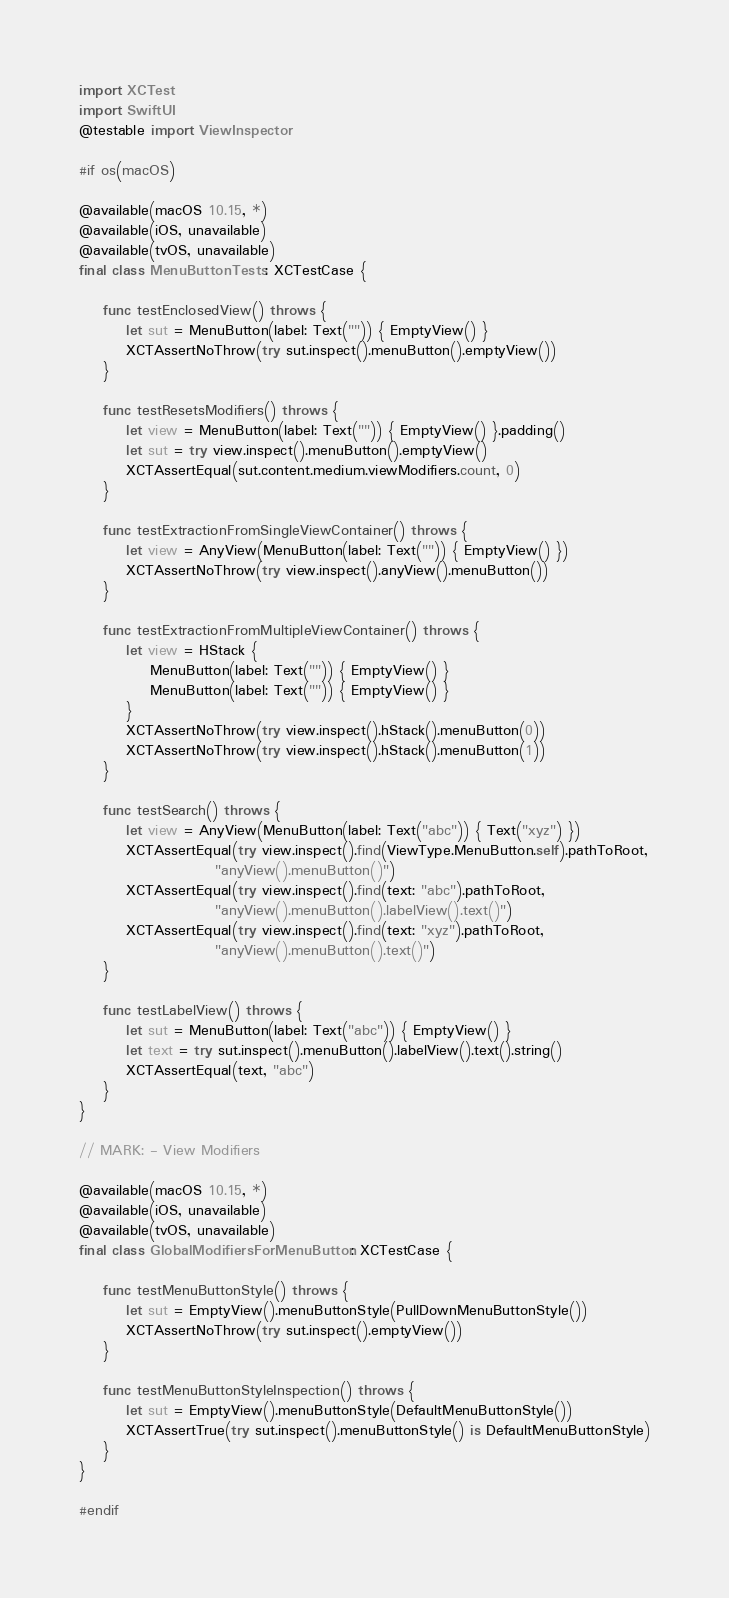Convert code to text. <code><loc_0><loc_0><loc_500><loc_500><_Swift_>import XCTest
import SwiftUI
@testable import ViewInspector

#if os(macOS)

@available(macOS 10.15, *)
@available(iOS, unavailable)
@available(tvOS, unavailable)
final class MenuButtonTests: XCTestCase {
    
    func testEnclosedView() throws {
        let sut = MenuButton(label: Text("")) { EmptyView() }
        XCTAssertNoThrow(try sut.inspect().menuButton().emptyView())
    }
    
    func testResetsModifiers() throws {
        let view = MenuButton(label: Text("")) { EmptyView() }.padding()
        let sut = try view.inspect().menuButton().emptyView()
        XCTAssertEqual(sut.content.medium.viewModifiers.count, 0)
    }
    
    func testExtractionFromSingleViewContainer() throws {
        let view = AnyView(MenuButton(label: Text("")) { EmptyView() })
        XCTAssertNoThrow(try view.inspect().anyView().menuButton())
    }
    
    func testExtractionFromMultipleViewContainer() throws {
        let view = HStack {
            MenuButton(label: Text("")) { EmptyView() }
            MenuButton(label: Text("")) { EmptyView() }
        }
        XCTAssertNoThrow(try view.inspect().hStack().menuButton(0))
        XCTAssertNoThrow(try view.inspect().hStack().menuButton(1))
    }
    
    func testSearch() throws {
        let view = AnyView(MenuButton(label: Text("abc")) { Text("xyz") })
        XCTAssertEqual(try view.inspect().find(ViewType.MenuButton.self).pathToRoot,
                       "anyView().menuButton()")
        XCTAssertEqual(try view.inspect().find(text: "abc").pathToRoot,
                       "anyView().menuButton().labelView().text()")
        XCTAssertEqual(try view.inspect().find(text: "xyz").pathToRoot,
                       "anyView().menuButton().text()")
    }
    
    func testLabelView() throws {
        let sut = MenuButton(label: Text("abc")) { EmptyView() }
        let text = try sut.inspect().menuButton().labelView().text().string()
        XCTAssertEqual(text, "abc")
    }
}

// MARK: - View Modifiers

@available(macOS 10.15, *)
@available(iOS, unavailable)
@available(tvOS, unavailable)
final class GlobalModifiersForMenuButton: XCTestCase {
    
    func testMenuButtonStyle() throws {
        let sut = EmptyView().menuButtonStyle(PullDownMenuButtonStyle())
        XCTAssertNoThrow(try sut.inspect().emptyView())
    }
    
    func testMenuButtonStyleInspection() throws {
        let sut = EmptyView().menuButtonStyle(DefaultMenuButtonStyle())
        XCTAssertTrue(try sut.inspect().menuButtonStyle() is DefaultMenuButtonStyle)
    }
}

#endif
</code> 